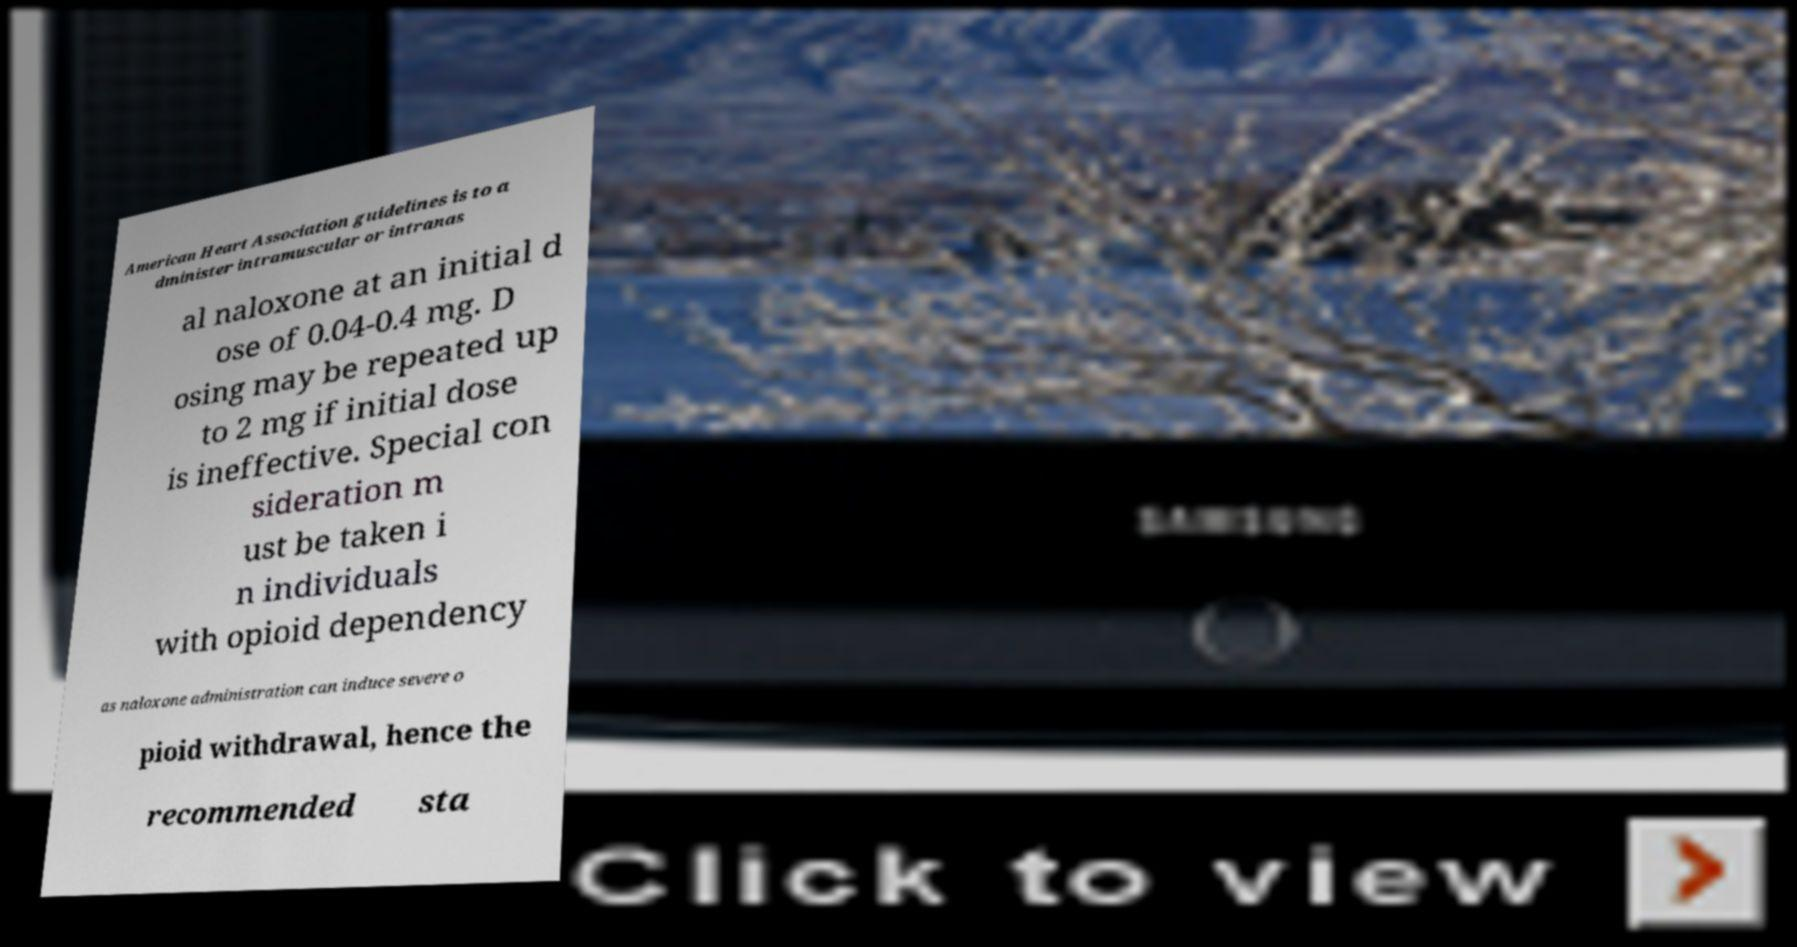What messages or text are displayed in this image? I need them in a readable, typed format. American Heart Association guidelines is to a dminister intramuscular or intranas al naloxone at an initial d ose of 0.04-0.4 mg. D osing may be repeated up to 2 mg if initial dose is ineffective. Special con sideration m ust be taken i n individuals with opioid dependency as naloxone administration can induce severe o pioid withdrawal, hence the recommended sta 